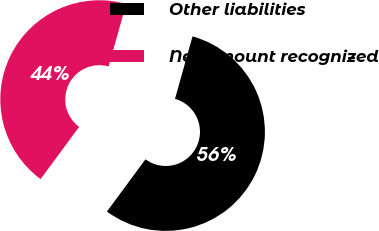<chart> <loc_0><loc_0><loc_500><loc_500><pie_chart><fcel>Other liabilities<fcel>Net amount recognized<nl><fcel>55.77%<fcel>44.23%<nl></chart> 